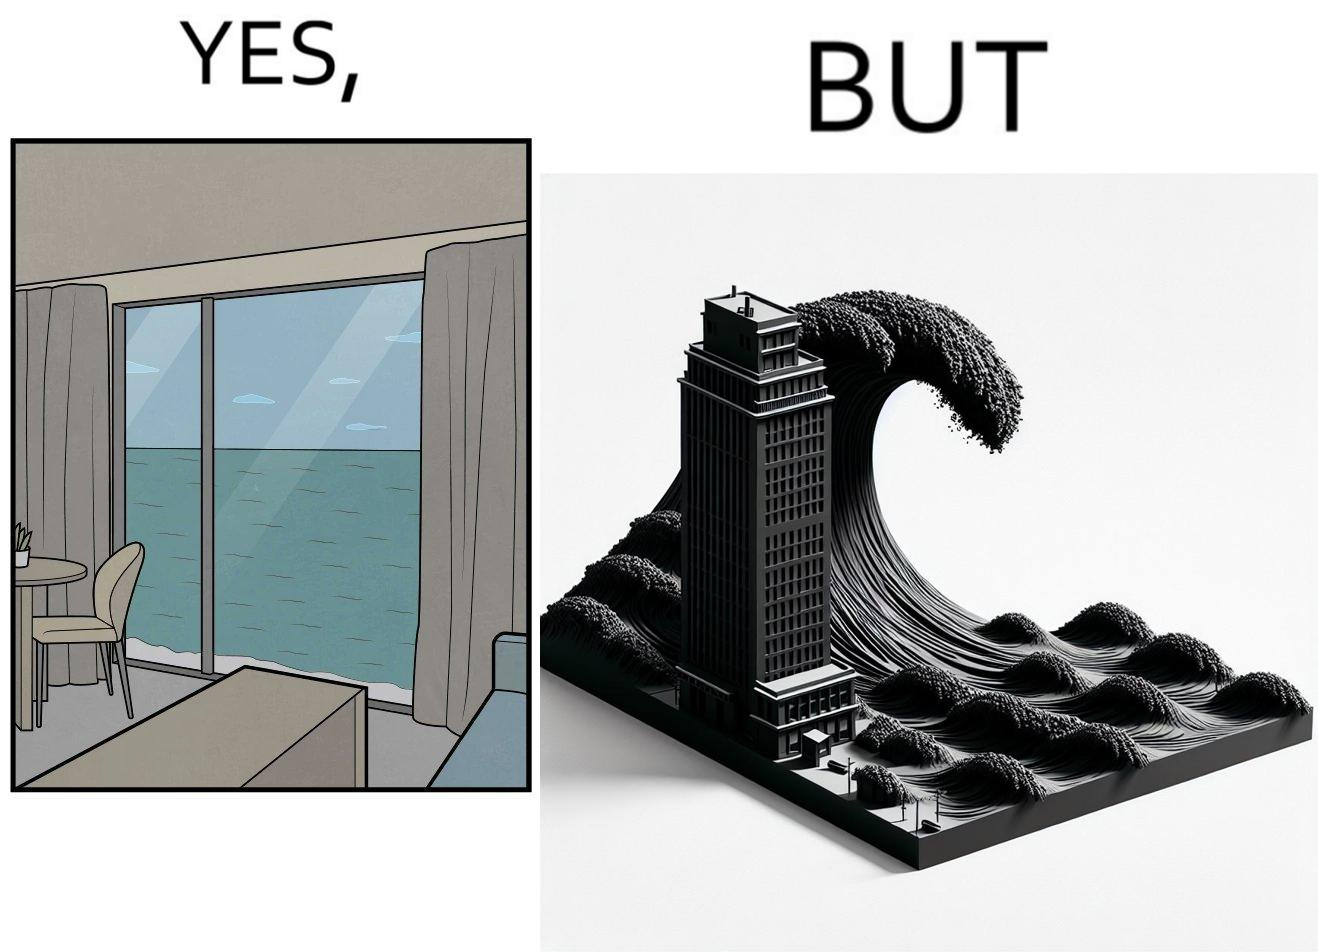What does this image depict? The same sea which gives us a relaxation on a normal day can pose a danger to us sometimes like during a tsunami 